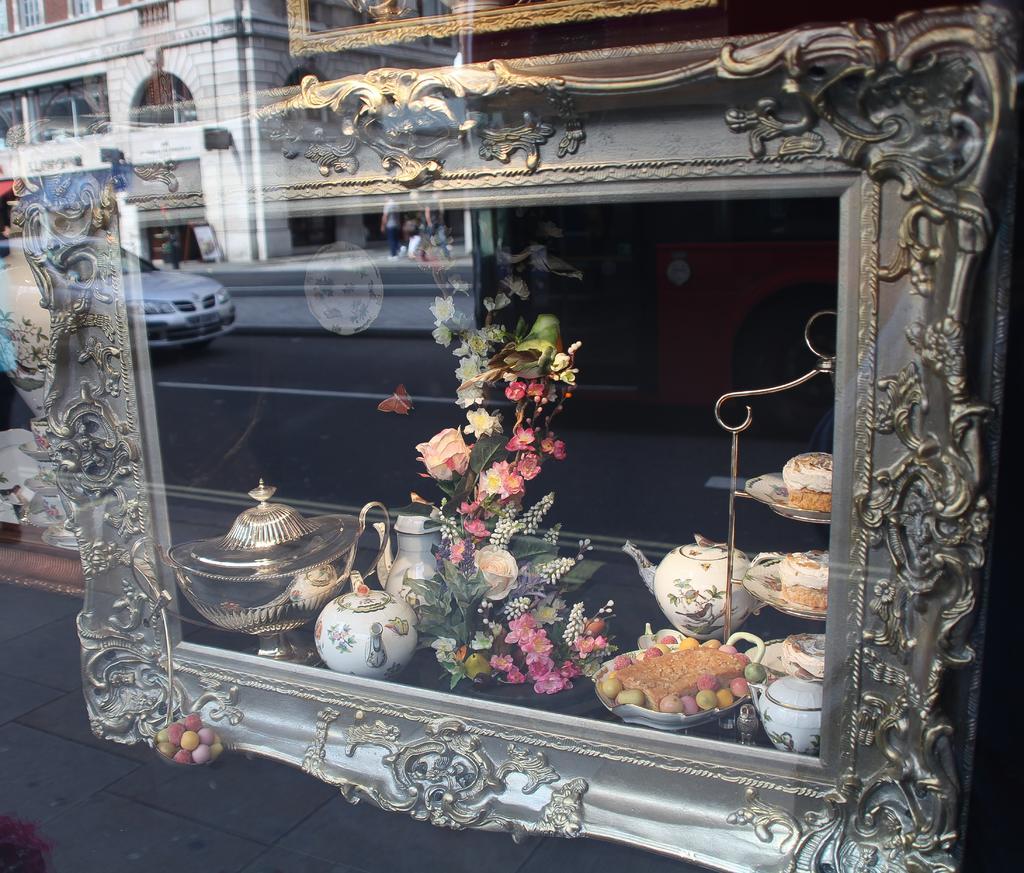Could you give a brief overview of what you see in this image? In this image I can see it is the glass wall, in this there are things made up of porcelain. On the left side there is a reflected image of a building and a car is moving on the road. 